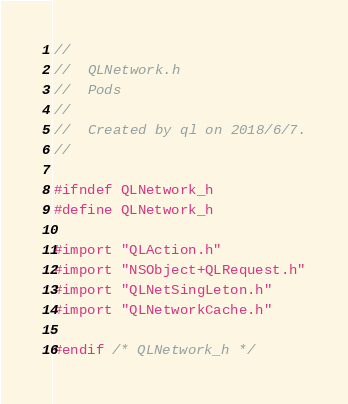<code> <loc_0><loc_0><loc_500><loc_500><_C_>//
//  QLNetwork.h
//  Pods
//
//  Created by ql on 2018/6/7.
//

#ifndef QLNetwork_h
#define QLNetwork_h

#import "QLAction.h"
#import "NSObject+QLRequest.h"
#import "QLNetSingLeton.h"
#import "QLNetworkCache.h"

#endif /* QLNetwork_h */
</code> 